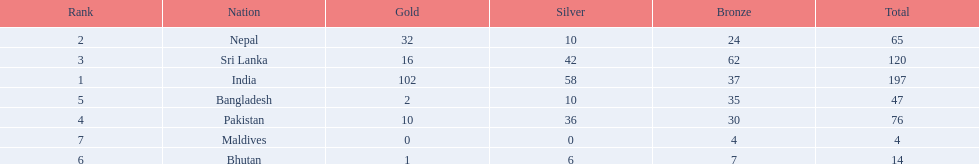How many gold medals were won by the teams? 102, 32, 16, 10, 2, 1, 0. What country won no gold medals? Maldives. 